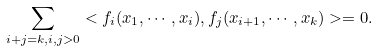<formula> <loc_0><loc_0><loc_500><loc_500>\sum _ { i + j = k , i , j > 0 } < f _ { i } ( x _ { 1 } , \cdots , x _ { i } ) , f _ { j } ( x _ { i + 1 } , \cdots , x _ { k } ) > = 0 .</formula> 